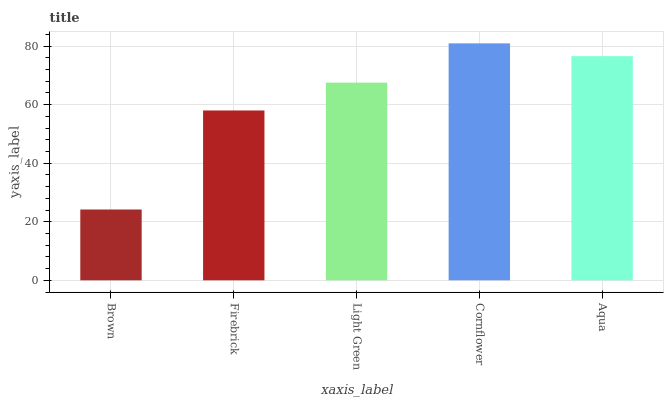Is Brown the minimum?
Answer yes or no. Yes. Is Cornflower the maximum?
Answer yes or no. Yes. Is Firebrick the minimum?
Answer yes or no. No. Is Firebrick the maximum?
Answer yes or no. No. Is Firebrick greater than Brown?
Answer yes or no. Yes. Is Brown less than Firebrick?
Answer yes or no. Yes. Is Brown greater than Firebrick?
Answer yes or no. No. Is Firebrick less than Brown?
Answer yes or no. No. Is Light Green the high median?
Answer yes or no. Yes. Is Light Green the low median?
Answer yes or no. Yes. Is Cornflower the high median?
Answer yes or no. No. Is Aqua the low median?
Answer yes or no. No. 